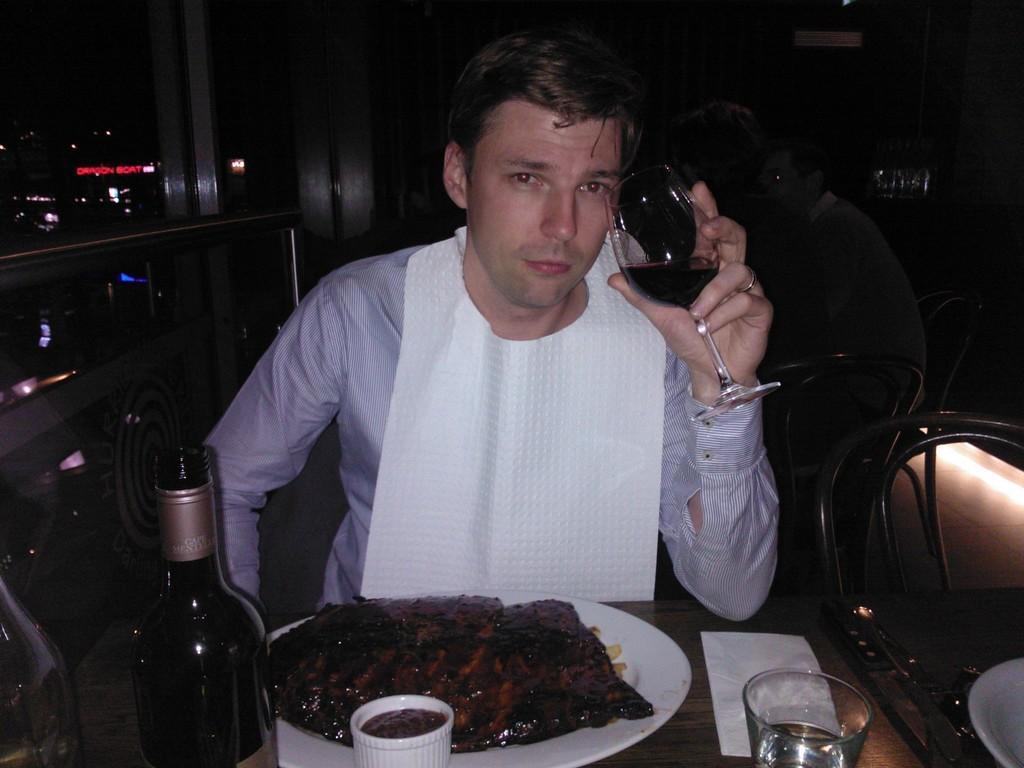How would you summarize this image in a sentence or two? This picture is of inside. In the foreground we can see a man wearing blue color shirt, holding the glass of drink and sitting on the chair, in front of him there is a table, on the top of which a plate of food, a bottle and glasses are placed. In the background we can see the group of persons sitting on the chairs and a wall. 